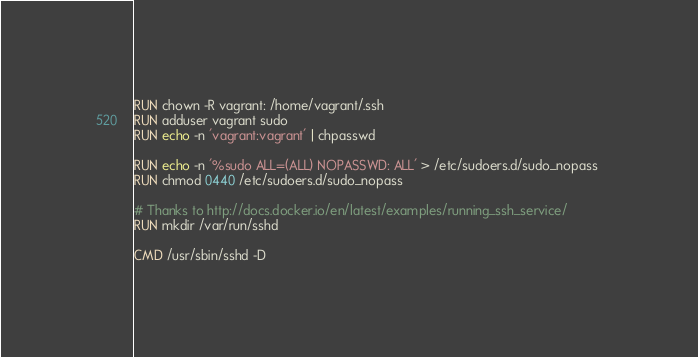<code> <loc_0><loc_0><loc_500><loc_500><_Dockerfile_>RUN chown -R vagrant: /home/vagrant/.ssh
RUN adduser vagrant sudo
RUN echo -n 'vagrant:vagrant' | chpasswd

RUN echo -n '%sudo ALL=(ALL) NOPASSWD: ALL' > /etc/sudoers.d/sudo_nopass 
RUN chmod 0440 /etc/sudoers.d/sudo_nopass

# Thanks to http://docs.docker.io/en/latest/examples/running_ssh_service/
RUN mkdir /var/run/sshd

CMD /usr/sbin/sshd -D
</code> 